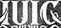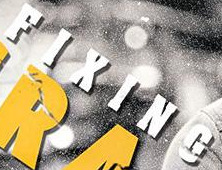Identify the words shown in these images in order, separated by a semicolon. IUIC; FIXING 